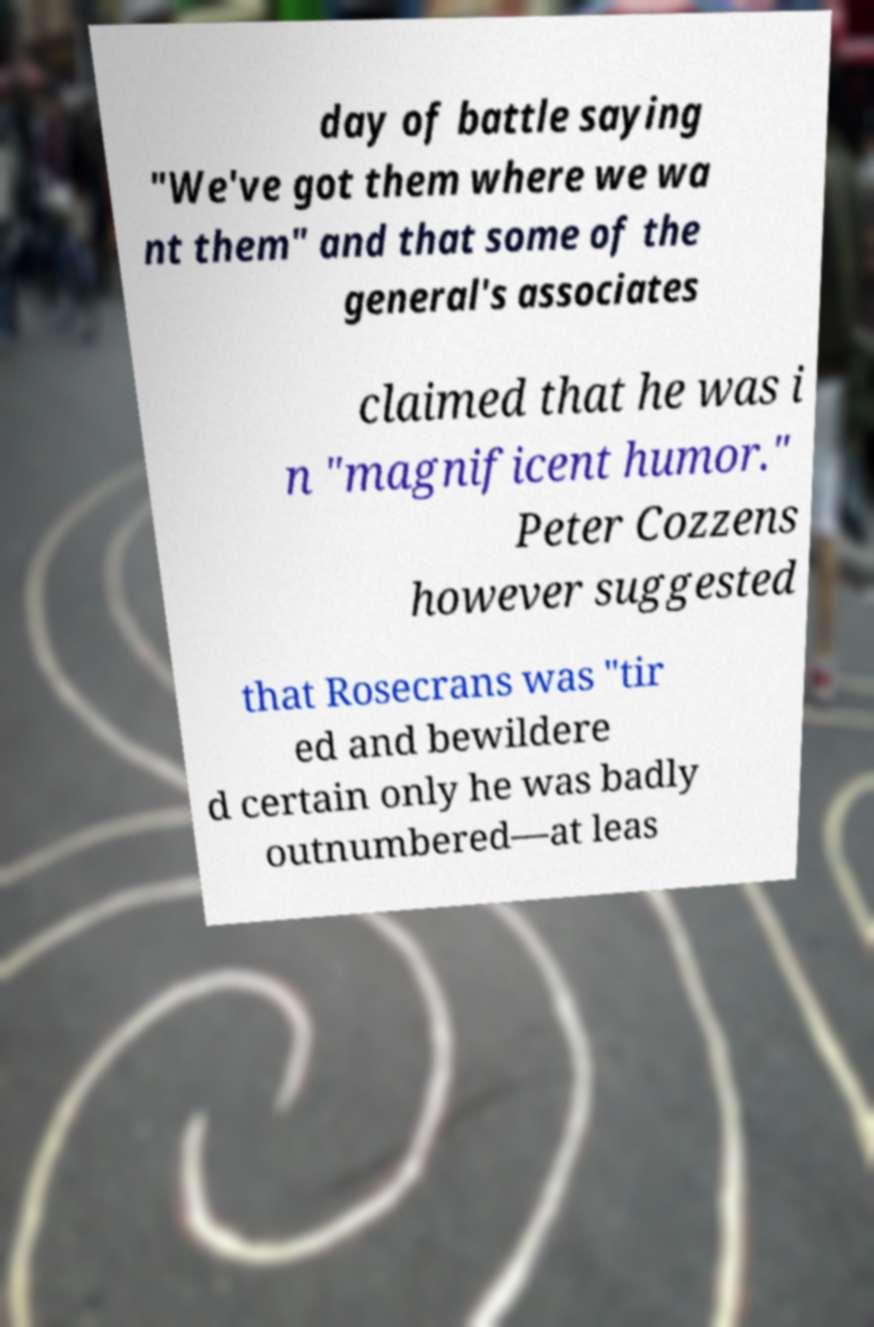There's text embedded in this image that I need extracted. Can you transcribe it verbatim? day of battle saying "We've got them where we wa nt them" and that some of the general's associates claimed that he was i n "magnificent humor." Peter Cozzens however suggested that Rosecrans was "tir ed and bewildere d certain only he was badly outnumbered—at leas 